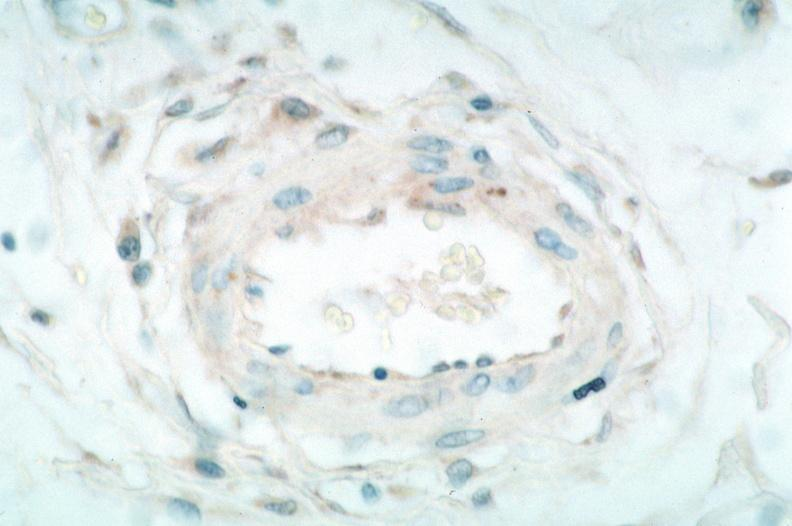s myocardium present?
Answer the question using a single word or phrase. No 